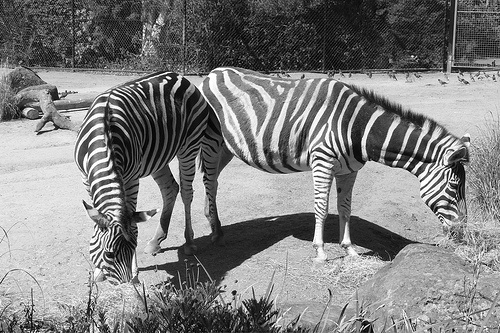Describe the objects in this image and their specific colors. I can see zebra in black, gray, lightgray, and darkgray tones, zebra in black, gray, lightgray, and darkgray tones, bird in black, darkgray, gray, and lightgray tones, bird in black, gray, darkgray, and lightgray tones, and bird in black, lightgray, darkgray, and gray tones in this image. 